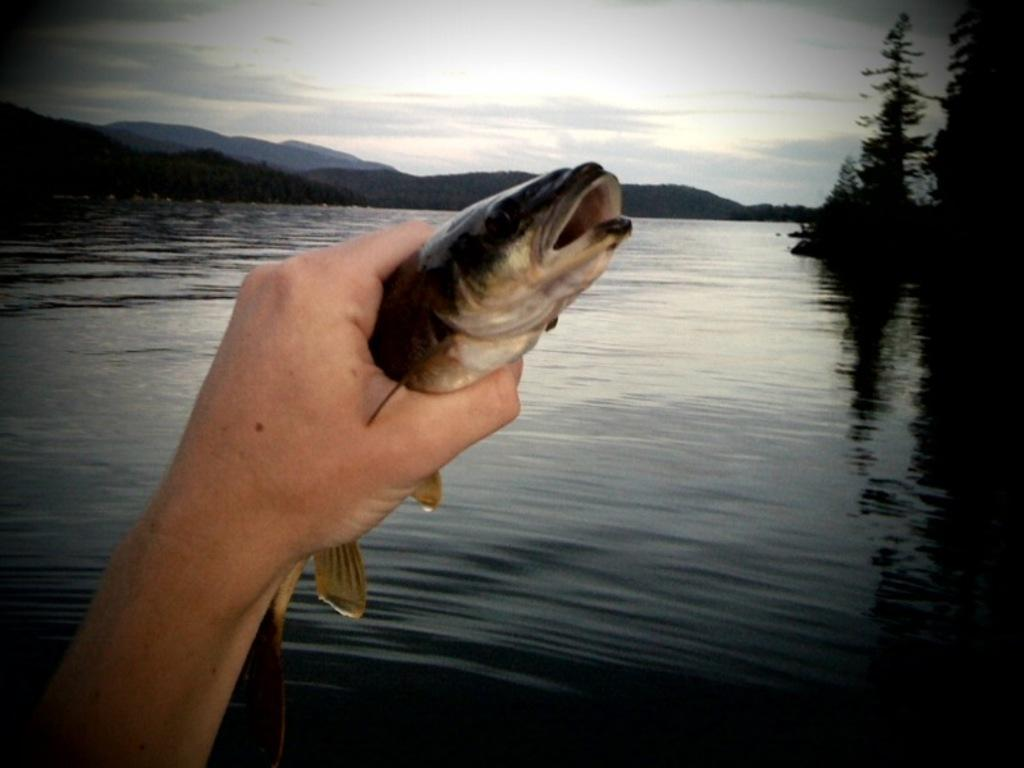What is the person in the image holding? The person is holding a fish in the image. What can be seen in the background of the image? There is a river, trees, mountains, and a clear sky in the background of the image. How many natural features are visible in the background? There are three natural features visible in the background: a river, trees, and mountains. What type of stove can be seen in the image? There is no stove present in the image. How many blades are visible in the image? There are no blades visible in the image. 